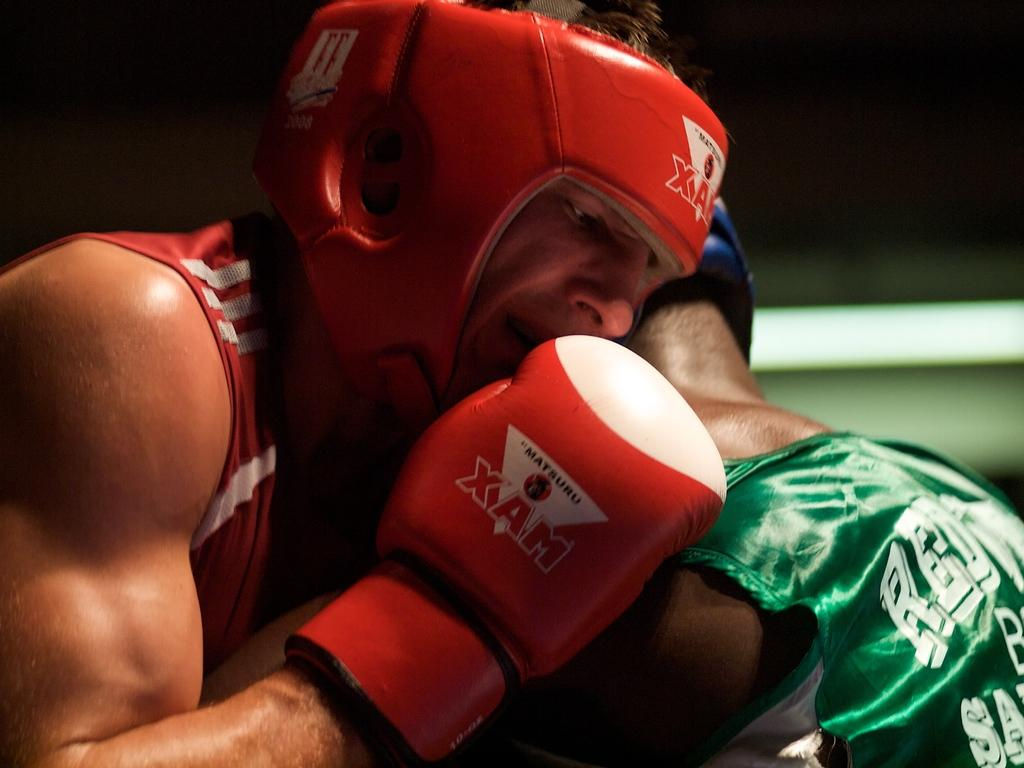<image>
Write a terse but informative summary of the picture. A boxer wears XAM boxing gloves when he's fighting in the ring. 